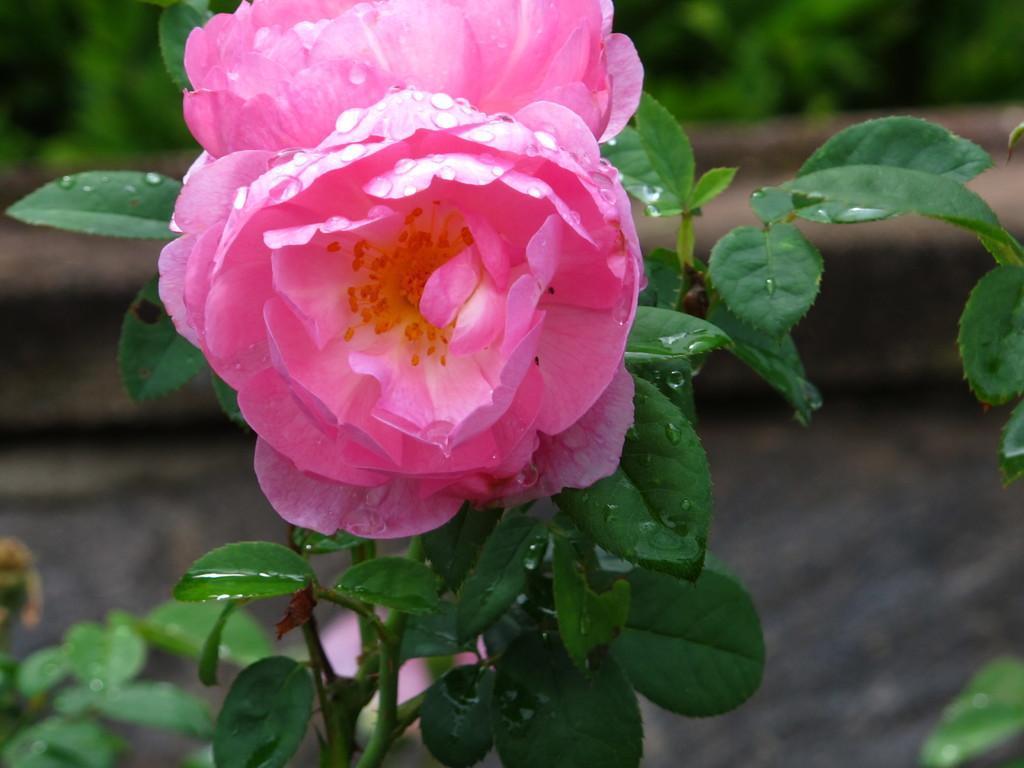In one or two sentences, can you explain what this image depicts? In this picture I can see flowers to the plant and looks like few plants in the back. 